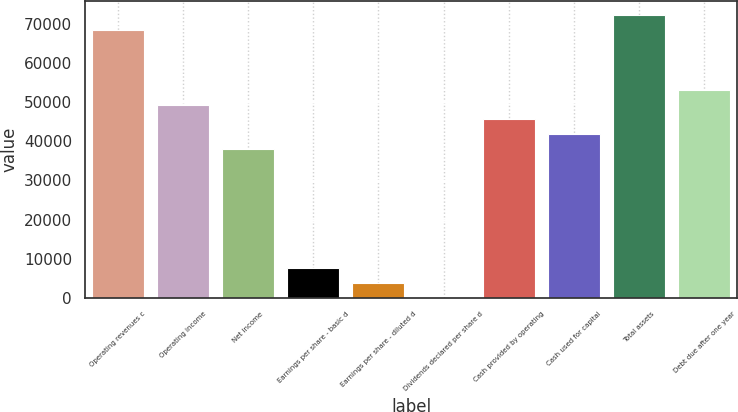Convert chart to OTSL. <chart><loc_0><loc_0><loc_500><loc_500><bar_chart><fcel>Operating revenues c<fcel>Operating income<fcel>Net income<fcel>Earnings per share - basic d<fcel>Earnings per share - diluted d<fcel>Dividends declared per share d<fcel>Cash provided by operating<fcel>Cash used for capital<fcel>Total assets<fcel>Debt due after one year<nl><fcel>68458.9<fcel>49442.7<fcel>38033<fcel>7607.2<fcel>3803.97<fcel>0.74<fcel>45639.5<fcel>41836.3<fcel>72262.1<fcel>53246<nl></chart> 